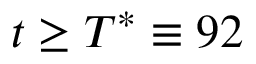Convert formula to latex. <formula><loc_0><loc_0><loc_500><loc_500>t \geq T ^ { * } \equiv 9 2</formula> 